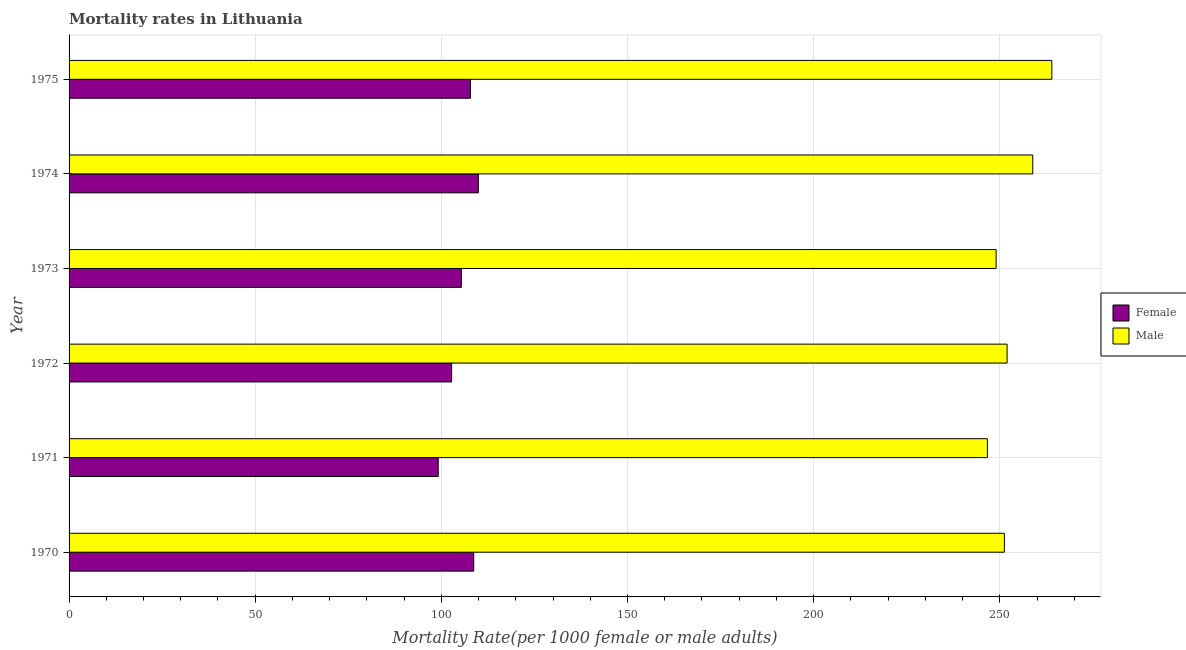How many groups of bars are there?
Make the answer very short. 6. Are the number of bars on each tick of the Y-axis equal?
Give a very brief answer. Yes. How many bars are there on the 5th tick from the bottom?
Give a very brief answer. 2. What is the male mortality rate in 1970?
Ensure brevity in your answer.  251.24. Across all years, what is the maximum male mortality rate?
Your answer should be very brief. 263.99. Across all years, what is the minimum female mortality rate?
Your response must be concise. 99.16. In which year was the male mortality rate maximum?
Give a very brief answer. 1975. What is the total female mortality rate in the graph?
Give a very brief answer. 633.75. What is the difference between the male mortality rate in 1974 and that in 1975?
Your answer should be compact. -5.13. What is the difference between the male mortality rate in 1972 and the female mortality rate in 1973?
Your response must be concise. 146.59. What is the average female mortality rate per year?
Keep it short and to the point. 105.62. In the year 1971, what is the difference between the male mortality rate and female mortality rate?
Your answer should be compact. 147.52. In how many years, is the male mortality rate greater than 230 ?
Your answer should be very brief. 6. What is the ratio of the female mortality rate in 1970 to that in 1975?
Offer a very short reply. 1.01. Is the male mortality rate in 1970 less than that in 1972?
Make the answer very short. Yes. Is the difference between the female mortality rate in 1971 and 1972 greater than the difference between the male mortality rate in 1971 and 1972?
Make the answer very short. Yes. What is the difference between the highest and the second highest female mortality rate?
Your answer should be compact. 1.25. What is the difference between the highest and the lowest female mortality rate?
Your answer should be very brief. 10.79. Is the sum of the male mortality rate in 1970 and 1972 greater than the maximum female mortality rate across all years?
Give a very brief answer. Yes. Are all the bars in the graph horizontal?
Provide a succinct answer. Yes. How many years are there in the graph?
Keep it short and to the point. 6. What is the difference between two consecutive major ticks on the X-axis?
Make the answer very short. 50. Are the values on the major ticks of X-axis written in scientific E-notation?
Give a very brief answer. No. Does the graph contain any zero values?
Offer a terse response. No. Does the graph contain grids?
Your answer should be very brief. Yes. How are the legend labels stacked?
Offer a very short reply. Vertical. What is the title of the graph?
Keep it short and to the point. Mortality rates in Lithuania. What is the label or title of the X-axis?
Your answer should be compact. Mortality Rate(per 1000 female or male adults). What is the Mortality Rate(per 1000 female or male adults) of Female in 1970?
Give a very brief answer. 108.7. What is the Mortality Rate(per 1000 female or male adults) in Male in 1970?
Make the answer very short. 251.24. What is the Mortality Rate(per 1000 female or male adults) of Female in 1971?
Ensure brevity in your answer.  99.16. What is the Mortality Rate(per 1000 female or male adults) of Male in 1971?
Offer a terse response. 246.68. What is the Mortality Rate(per 1000 female or male adults) in Female in 1972?
Your answer should be very brief. 102.76. What is the Mortality Rate(per 1000 female or male adults) of Male in 1972?
Ensure brevity in your answer.  251.97. What is the Mortality Rate(per 1000 female or male adults) in Female in 1973?
Your response must be concise. 105.37. What is the Mortality Rate(per 1000 female or male adults) in Male in 1973?
Provide a succinct answer. 249.02. What is the Mortality Rate(per 1000 female or male adults) in Female in 1974?
Provide a succinct answer. 109.95. What is the Mortality Rate(per 1000 female or male adults) in Male in 1974?
Give a very brief answer. 258.86. What is the Mortality Rate(per 1000 female or male adults) of Female in 1975?
Offer a very short reply. 107.81. What is the Mortality Rate(per 1000 female or male adults) in Male in 1975?
Provide a succinct answer. 263.99. Across all years, what is the maximum Mortality Rate(per 1000 female or male adults) of Female?
Your answer should be compact. 109.95. Across all years, what is the maximum Mortality Rate(per 1000 female or male adults) of Male?
Your answer should be compact. 263.99. Across all years, what is the minimum Mortality Rate(per 1000 female or male adults) of Female?
Offer a very short reply. 99.16. Across all years, what is the minimum Mortality Rate(per 1000 female or male adults) of Male?
Give a very brief answer. 246.68. What is the total Mortality Rate(per 1000 female or male adults) in Female in the graph?
Offer a terse response. 633.75. What is the total Mortality Rate(per 1000 female or male adults) in Male in the graph?
Provide a succinct answer. 1521.76. What is the difference between the Mortality Rate(per 1000 female or male adults) in Female in 1970 and that in 1971?
Your answer should be very brief. 9.54. What is the difference between the Mortality Rate(per 1000 female or male adults) of Male in 1970 and that in 1971?
Provide a short and direct response. 4.56. What is the difference between the Mortality Rate(per 1000 female or male adults) of Female in 1970 and that in 1972?
Provide a succinct answer. 5.94. What is the difference between the Mortality Rate(per 1000 female or male adults) in Male in 1970 and that in 1972?
Make the answer very short. -0.72. What is the difference between the Mortality Rate(per 1000 female or male adults) in Female in 1970 and that in 1973?
Provide a short and direct response. 3.33. What is the difference between the Mortality Rate(per 1000 female or male adults) in Male in 1970 and that in 1973?
Ensure brevity in your answer.  2.22. What is the difference between the Mortality Rate(per 1000 female or male adults) of Female in 1970 and that in 1974?
Your answer should be compact. -1.25. What is the difference between the Mortality Rate(per 1000 female or male adults) in Male in 1970 and that in 1974?
Your answer should be compact. -7.62. What is the difference between the Mortality Rate(per 1000 female or male adults) of Female in 1970 and that in 1975?
Provide a succinct answer. 0.89. What is the difference between the Mortality Rate(per 1000 female or male adults) in Male in 1970 and that in 1975?
Offer a very short reply. -12.74. What is the difference between the Mortality Rate(per 1000 female or male adults) in Female in 1971 and that in 1972?
Provide a succinct answer. -3.6. What is the difference between the Mortality Rate(per 1000 female or male adults) of Male in 1971 and that in 1972?
Make the answer very short. -5.29. What is the difference between the Mortality Rate(per 1000 female or male adults) of Female in 1971 and that in 1973?
Provide a short and direct response. -6.21. What is the difference between the Mortality Rate(per 1000 female or male adults) of Male in 1971 and that in 1973?
Keep it short and to the point. -2.34. What is the difference between the Mortality Rate(per 1000 female or male adults) of Female in 1971 and that in 1974?
Your answer should be very brief. -10.79. What is the difference between the Mortality Rate(per 1000 female or male adults) in Male in 1971 and that in 1974?
Ensure brevity in your answer.  -12.18. What is the difference between the Mortality Rate(per 1000 female or male adults) of Female in 1971 and that in 1975?
Offer a terse response. -8.64. What is the difference between the Mortality Rate(per 1000 female or male adults) of Male in 1971 and that in 1975?
Provide a short and direct response. -17.31. What is the difference between the Mortality Rate(per 1000 female or male adults) of Female in 1972 and that in 1973?
Offer a terse response. -2.61. What is the difference between the Mortality Rate(per 1000 female or male adults) of Male in 1972 and that in 1973?
Offer a terse response. 2.94. What is the difference between the Mortality Rate(per 1000 female or male adults) of Female in 1972 and that in 1974?
Keep it short and to the point. -7.18. What is the difference between the Mortality Rate(per 1000 female or male adults) of Male in 1972 and that in 1974?
Provide a succinct answer. -6.89. What is the difference between the Mortality Rate(per 1000 female or male adults) in Female in 1972 and that in 1975?
Provide a short and direct response. -5.04. What is the difference between the Mortality Rate(per 1000 female or male adults) of Male in 1972 and that in 1975?
Your answer should be very brief. -12.02. What is the difference between the Mortality Rate(per 1000 female or male adults) in Female in 1973 and that in 1974?
Offer a very short reply. -4.58. What is the difference between the Mortality Rate(per 1000 female or male adults) in Male in 1973 and that in 1974?
Make the answer very short. -9.84. What is the difference between the Mortality Rate(per 1000 female or male adults) in Female in 1973 and that in 1975?
Make the answer very short. -2.43. What is the difference between the Mortality Rate(per 1000 female or male adults) of Male in 1973 and that in 1975?
Provide a short and direct response. -14.96. What is the difference between the Mortality Rate(per 1000 female or male adults) in Female in 1974 and that in 1975?
Offer a terse response. 2.14. What is the difference between the Mortality Rate(per 1000 female or male adults) of Male in 1974 and that in 1975?
Provide a short and direct response. -5.13. What is the difference between the Mortality Rate(per 1000 female or male adults) in Female in 1970 and the Mortality Rate(per 1000 female or male adults) in Male in 1971?
Provide a short and direct response. -137.98. What is the difference between the Mortality Rate(per 1000 female or male adults) in Female in 1970 and the Mortality Rate(per 1000 female or male adults) in Male in 1972?
Your answer should be compact. -143.27. What is the difference between the Mortality Rate(per 1000 female or male adults) in Female in 1970 and the Mortality Rate(per 1000 female or male adults) in Male in 1973?
Ensure brevity in your answer.  -140.32. What is the difference between the Mortality Rate(per 1000 female or male adults) of Female in 1970 and the Mortality Rate(per 1000 female or male adults) of Male in 1974?
Your answer should be compact. -150.16. What is the difference between the Mortality Rate(per 1000 female or male adults) in Female in 1970 and the Mortality Rate(per 1000 female or male adults) in Male in 1975?
Provide a short and direct response. -155.29. What is the difference between the Mortality Rate(per 1000 female or male adults) of Female in 1971 and the Mortality Rate(per 1000 female or male adults) of Male in 1972?
Your response must be concise. -152.81. What is the difference between the Mortality Rate(per 1000 female or male adults) in Female in 1971 and the Mortality Rate(per 1000 female or male adults) in Male in 1973?
Make the answer very short. -149.86. What is the difference between the Mortality Rate(per 1000 female or male adults) of Female in 1971 and the Mortality Rate(per 1000 female or male adults) of Male in 1974?
Make the answer very short. -159.7. What is the difference between the Mortality Rate(per 1000 female or male adults) of Female in 1971 and the Mortality Rate(per 1000 female or male adults) of Male in 1975?
Provide a short and direct response. -164.83. What is the difference between the Mortality Rate(per 1000 female or male adults) in Female in 1972 and the Mortality Rate(per 1000 female or male adults) in Male in 1973?
Your response must be concise. -146.26. What is the difference between the Mortality Rate(per 1000 female or male adults) in Female in 1972 and the Mortality Rate(per 1000 female or male adults) in Male in 1974?
Offer a very short reply. -156.1. What is the difference between the Mortality Rate(per 1000 female or male adults) of Female in 1972 and the Mortality Rate(per 1000 female or male adults) of Male in 1975?
Offer a terse response. -161.22. What is the difference between the Mortality Rate(per 1000 female or male adults) in Female in 1973 and the Mortality Rate(per 1000 female or male adults) in Male in 1974?
Your response must be concise. -153.49. What is the difference between the Mortality Rate(per 1000 female or male adults) of Female in 1973 and the Mortality Rate(per 1000 female or male adults) of Male in 1975?
Give a very brief answer. -158.62. What is the difference between the Mortality Rate(per 1000 female or male adults) in Female in 1974 and the Mortality Rate(per 1000 female or male adults) in Male in 1975?
Your answer should be compact. -154.04. What is the average Mortality Rate(per 1000 female or male adults) in Female per year?
Provide a succinct answer. 105.62. What is the average Mortality Rate(per 1000 female or male adults) in Male per year?
Your answer should be compact. 253.63. In the year 1970, what is the difference between the Mortality Rate(per 1000 female or male adults) of Female and Mortality Rate(per 1000 female or male adults) of Male?
Give a very brief answer. -142.54. In the year 1971, what is the difference between the Mortality Rate(per 1000 female or male adults) of Female and Mortality Rate(per 1000 female or male adults) of Male?
Make the answer very short. -147.52. In the year 1972, what is the difference between the Mortality Rate(per 1000 female or male adults) of Female and Mortality Rate(per 1000 female or male adults) of Male?
Give a very brief answer. -149.2. In the year 1973, what is the difference between the Mortality Rate(per 1000 female or male adults) in Female and Mortality Rate(per 1000 female or male adults) in Male?
Ensure brevity in your answer.  -143.65. In the year 1974, what is the difference between the Mortality Rate(per 1000 female or male adults) in Female and Mortality Rate(per 1000 female or male adults) in Male?
Ensure brevity in your answer.  -148.91. In the year 1975, what is the difference between the Mortality Rate(per 1000 female or male adults) of Female and Mortality Rate(per 1000 female or male adults) of Male?
Give a very brief answer. -156.18. What is the ratio of the Mortality Rate(per 1000 female or male adults) of Female in 1970 to that in 1971?
Keep it short and to the point. 1.1. What is the ratio of the Mortality Rate(per 1000 female or male adults) in Male in 1970 to that in 1971?
Your response must be concise. 1.02. What is the ratio of the Mortality Rate(per 1000 female or male adults) in Female in 1970 to that in 1972?
Offer a very short reply. 1.06. What is the ratio of the Mortality Rate(per 1000 female or male adults) in Male in 1970 to that in 1972?
Provide a short and direct response. 1. What is the ratio of the Mortality Rate(per 1000 female or male adults) in Female in 1970 to that in 1973?
Keep it short and to the point. 1.03. What is the ratio of the Mortality Rate(per 1000 female or male adults) in Male in 1970 to that in 1973?
Give a very brief answer. 1.01. What is the ratio of the Mortality Rate(per 1000 female or male adults) in Female in 1970 to that in 1974?
Give a very brief answer. 0.99. What is the ratio of the Mortality Rate(per 1000 female or male adults) of Male in 1970 to that in 1974?
Offer a terse response. 0.97. What is the ratio of the Mortality Rate(per 1000 female or male adults) in Female in 1970 to that in 1975?
Your response must be concise. 1.01. What is the ratio of the Mortality Rate(per 1000 female or male adults) of Male in 1970 to that in 1975?
Give a very brief answer. 0.95. What is the ratio of the Mortality Rate(per 1000 female or male adults) of Female in 1971 to that in 1972?
Provide a short and direct response. 0.96. What is the ratio of the Mortality Rate(per 1000 female or male adults) in Male in 1971 to that in 1972?
Make the answer very short. 0.98. What is the ratio of the Mortality Rate(per 1000 female or male adults) in Female in 1971 to that in 1973?
Give a very brief answer. 0.94. What is the ratio of the Mortality Rate(per 1000 female or male adults) in Male in 1971 to that in 1973?
Your response must be concise. 0.99. What is the ratio of the Mortality Rate(per 1000 female or male adults) of Female in 1971 to that in 1974?
Your answer should be compact. 0.9. What is the ratio of the Mortality Rate(per 1000 female or male adults) in Male in 1971 to that in 1974?
Provide a succinct answer. 0.95. What is the ratio of the Mortality Rate(per 1000 female or male adults) of Female in 1971 to that in 1975?
Give a very brief answer. 0.92. What is the ratio of the Mortality Rate(per 1000 female or male adults) of Male in 1971 to that in 1975?
Offer a terse response. 0.93. What is the ratio of the Mortality Rate(per 1000 female or male adults) of Female in 1972 to that in 1973?
Provide a short and direct response. 0.98. What is the ratio of the Mortality Rate(per 1000 female or male adults) of Male in 1972 to that in 1973?
Make the answer very short. 1.01. What is the ratio of the Mortality Rate(per 1000 female or male adults) in Female in 1972 to that in 1974?
Provide a short and direct response. 0.93. What is the ratio of the Mortality Rate(per 1000 female or male adults) of Male in 1972 to that in 1974?
Keep it short and to the point. 0.97. What is the ratio of the Mortality Rate(per 1000 female or male adults) in Female in 1972 to that in 1975?
Provide a short and direct response. 0.95. What is the ratio of the Mortality Rate(per 1000 female or male adults) of Male in 1972 to that in 1975?
Your answer should be very brief. 0.95. What is the ratio of the Mortality Rate(per 1000 female or male adults) of Female in 1973 to that in 1974?
Your answer should be compact. 0.96. What is the ratio of the Mortality Rate(per 1000 female or male adults) of Male in 1973 to that in 1974?
Your answer should be compact. 0.96. What is the ratio of the Mortality Rate(per 1000 female or male adults) of Female in 1973 to that in 1975?
Keep it short and to the point. 0.98. What is the ratio of the Mortality Rate(per 1000 female or male adults) in Male in 1973 to that in 1975?
Provide a short and direct response. 0.94. What is the ratio of the Mortality Rate(per 1000 female or male adults) of Female in 1974 to that in 1975?
Your answer should be compact. 1.02. What is the ratio of the Mortality Rate(per 1000 female or male adults) in Male in 1974 to that in 1975?
Provide a short and direct response. 0.98. What is the difference between the highest and the second highest Mortality Rate(per 1000 female or male adults) of Female?
Your response must be concise. 1.25. What is the difference between the highest and the second highest Mortality Rate(per 1000 female or male adults) in Male?
Provide a succinct answer. 5.13. What is the difference between the highest and the lowest Mortality Rate(per 1000 female or male adults) of Female?
Keep it short and to the point. 10.79. What is the difference between the highest and the lowest Mortality Rate(per 1000 female or male adults) of Male?
Your response must be concise. 17.31. 